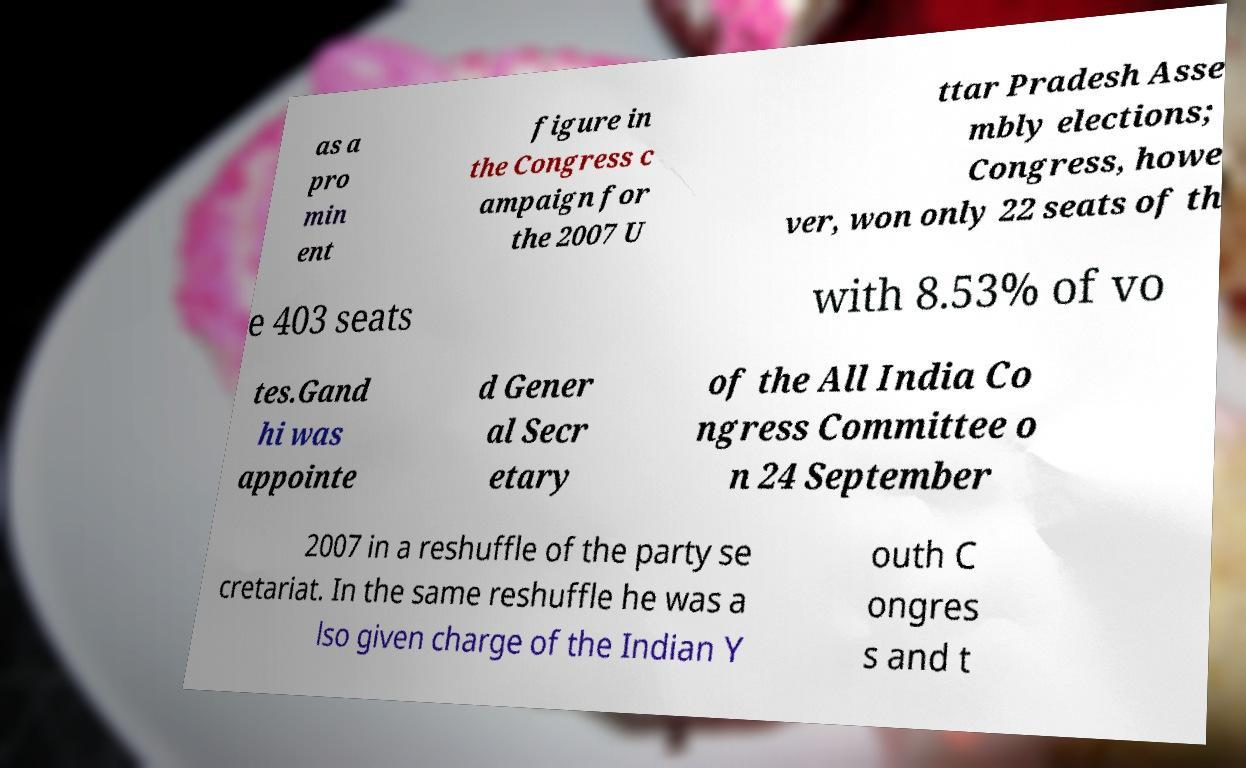What messages or text are displayed in this image? I need them in a readable, typed format. as a pro min ent figure in the Congress c ampaign for the 2007 U ttar Pradesh Asse mbly elections; Congress, howe ver, won only 22 seats of th e 403 seats with 8.53% of vo tes.Gand hi was appointe d Gener al Secr etary of the All India Co ngress Committee o n 24 September 2007 in a reshuffle of the party se cretariat. In the same reshuffle he was a lso given charge of the Indian Y outh C ongres s and t 